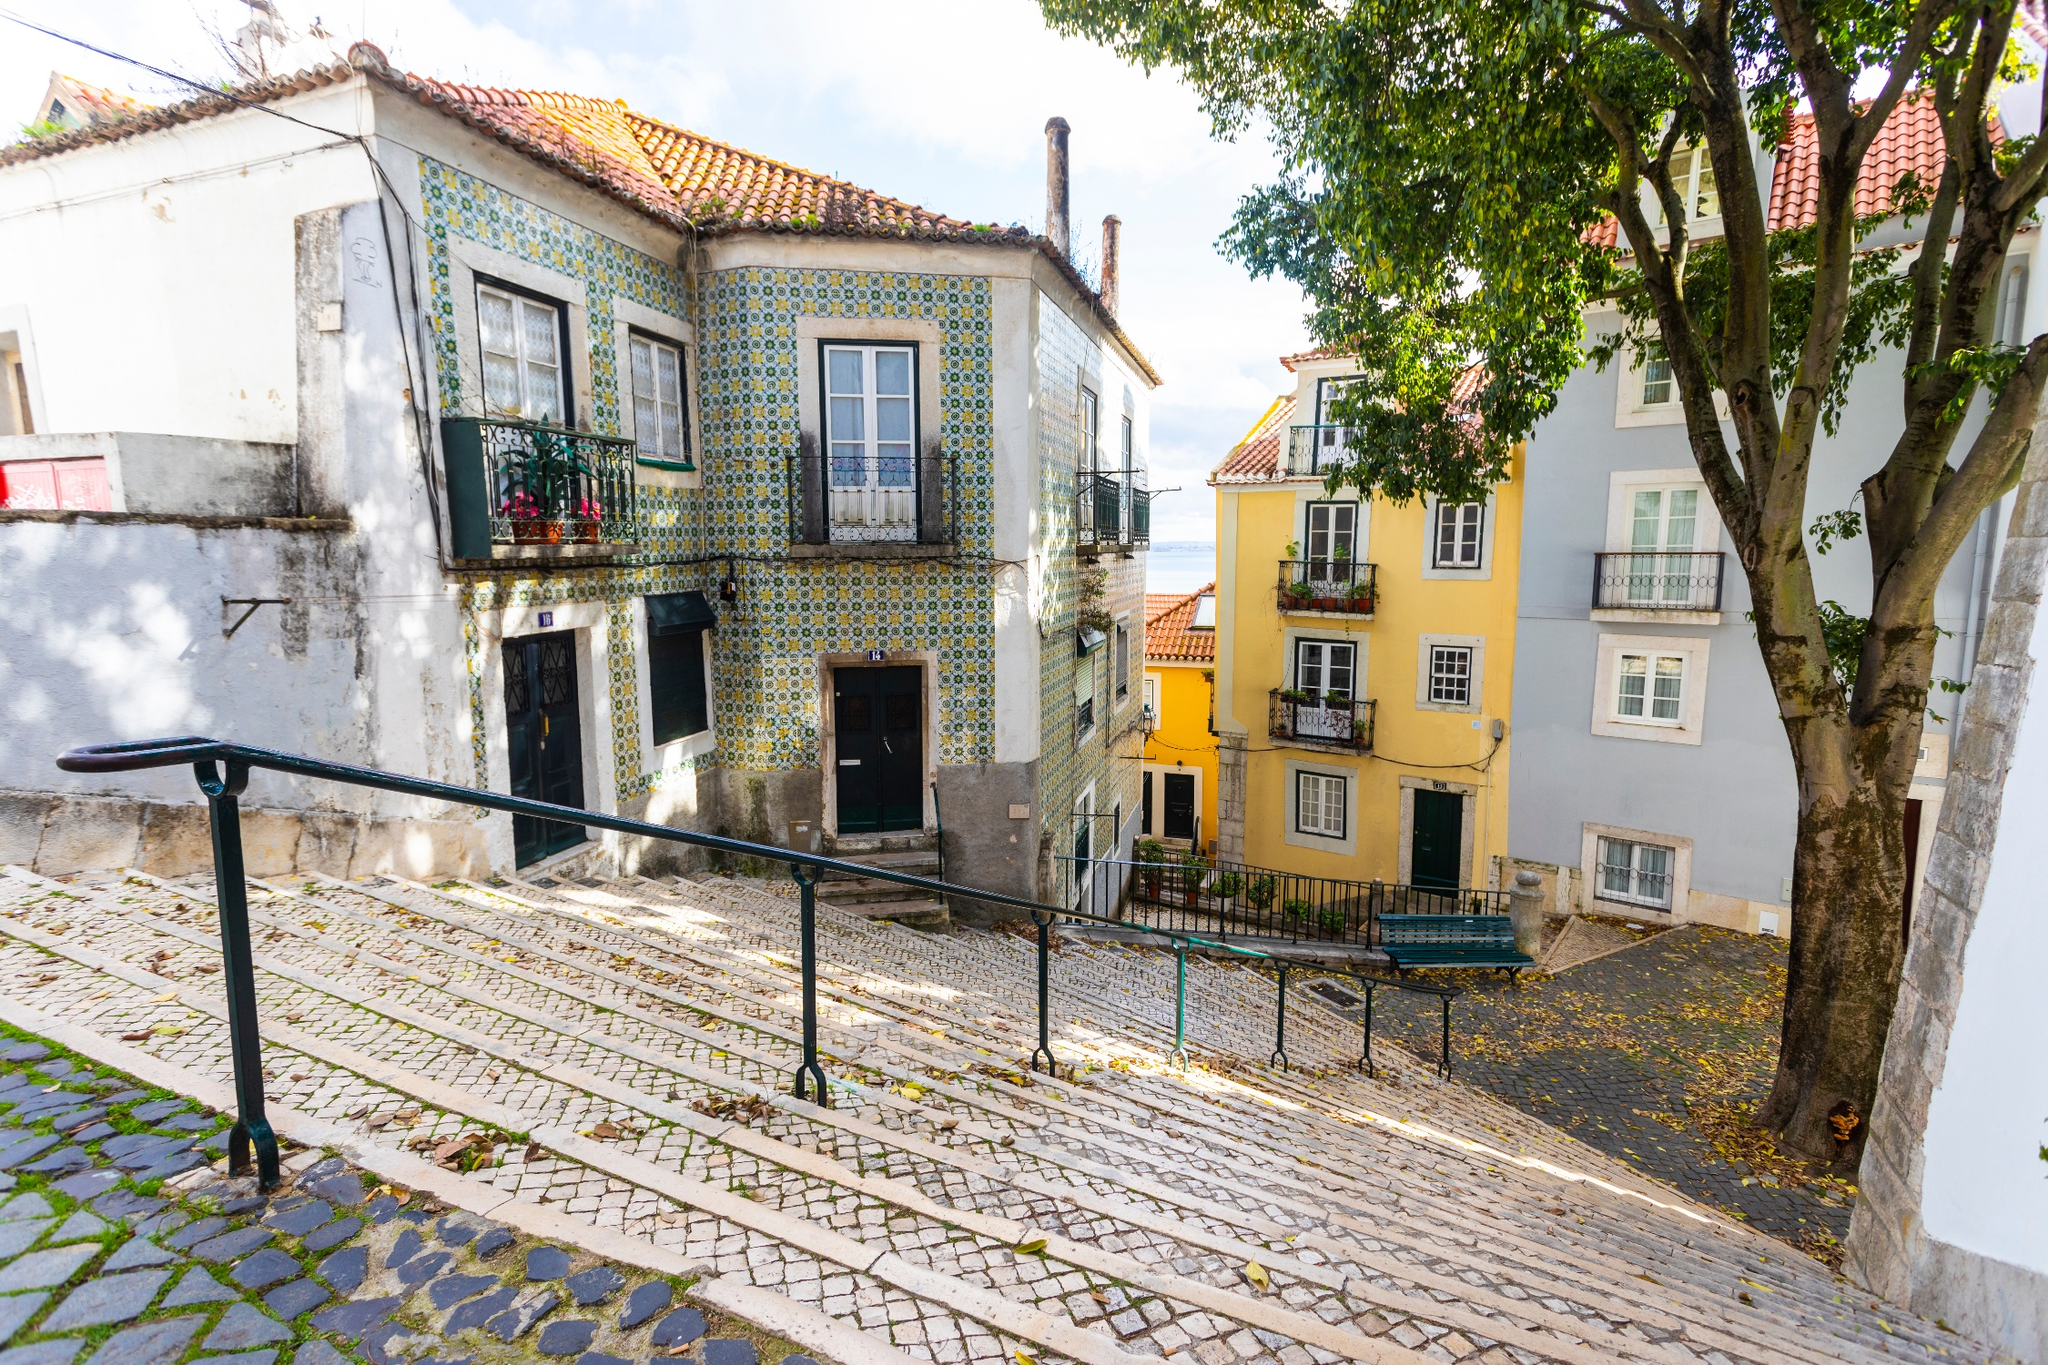What are some possible historical events that could have taken place on this street? This street might have witnessed various historical events over the years. During the age of explorers, it could have been a bustling pathway leading to the ports where ships set sail for the New World. It might have seen merchants trading exotic goods brought from distant lands, artisans crafting tiles and pottery, and festivals celebrating local culture. The street could also have been a silent observer to moments of political change, perhaps echoing the footsteps of revolutionaries and thinkers who walked and conversed here. Each cobblestone could tell a story of resilience and transformation as Lisbon evolved through different eras. Visualize a festival happening on this street. What do you see? Visualizing a festival on this street, you would see vibrant decorations strewn across the facades, with colorful banners and lanterns adding a festive touch. Stalls line the street, offering traditional Portuguese foods, drinks, and artisanal crafts for sale. The aroma of grilled sardines and freshly baked pastries fills the air, mingling with the sound of cheerful music and laughter. People—both locals and tourists—fill the street, dancing, singing, and celebrating. Children run around with painted faces, while elderly couples sit on benches, watching the festivities with smiles. The street comes alive with energy, joy, and a sense of community, embodying the spirit of celebration. 